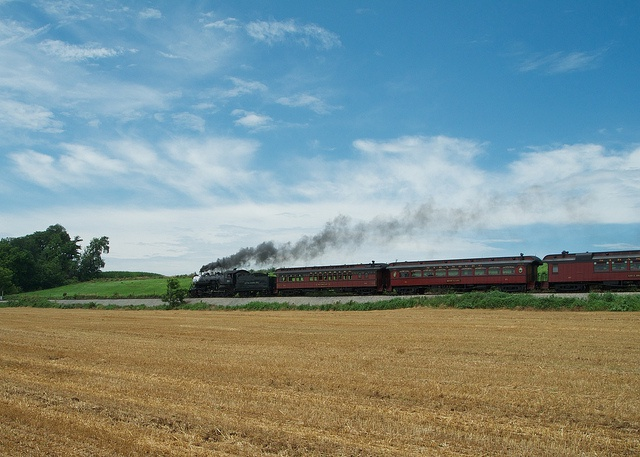Describe the objects in this image and their specific colors. I can see a train in lightblue, black, maroon, gray, and purple tones in this image. 